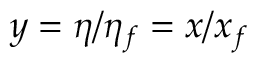<formula> <loc_0><loc_0><loc_500><loc_500>y = \eta / \eta _ { f } = x / x _ { f }</formula> 